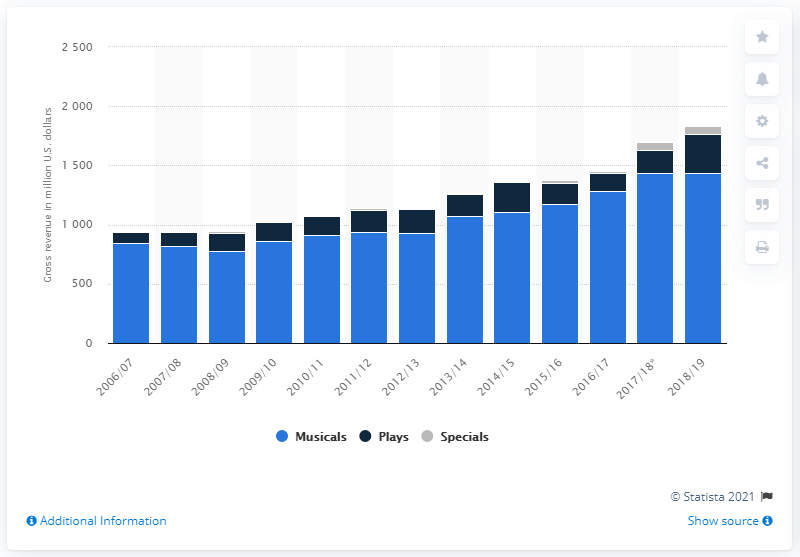Draw attention to some important aspects in this diagram. During the 2018/19 season, Broadway musicals generated a total of $1431.64 million in revenue. 